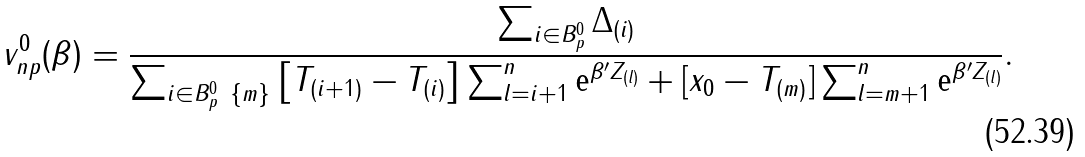Convert formula to latex. <formula><loc_0><loc_0><loc_500><loc_500>v _ { n p } ^ { 0 } ( \beta ) = \frac { \sum _ { i \in B _ { p } ^ { 0 } } \Delta _ { ( i ) } } { \sum _ { i \in B _ { p } ^ { 0 } \ \{ m \} } \left [ T _ { ( i + 1 ) } - T _ { ( i ) } \right ] \sum _ { l = i + 1 } ^ { n } \text {e} ^ { \beta ^ { \prime } Z _ { ( l ) } } + [ x _ { 0 } - T _ { ( m ) } ] \sum _ { l = m + 1 } ^ { n } \text {e} ^ { \beta ^ { \prime } Z _ { ( l ) } } } .</formula> 